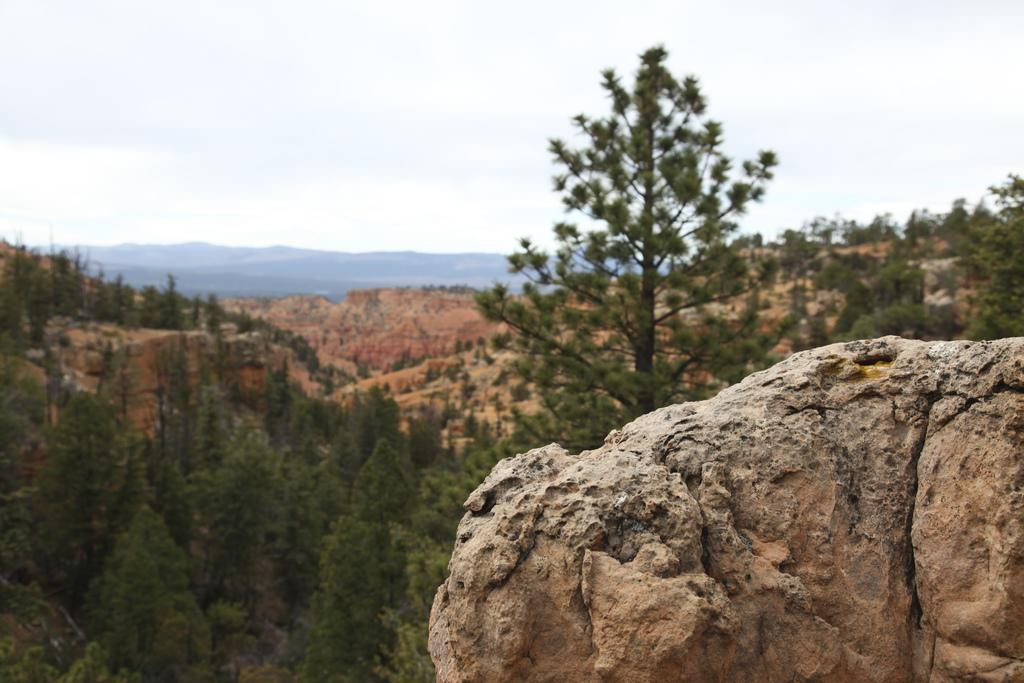What object can be seen on the right side of the image? There is a rock on the right side of the image. What type of landscape is visible in the background of the image? Hills and trees are visible in the background of the image. What is present in the sky in the image? There are clouds in the sky. What type of lawyer is part of the committee in the image? There is no lawyer or committee present in the image; it features a rock, hills, trees, and clouds. 